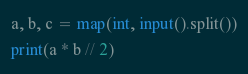<code> <loc_0><loc_0><loc_500><loc_500><_Python_>a, b, c = map(int, input().split())
print(a * b // 2)
</code> 